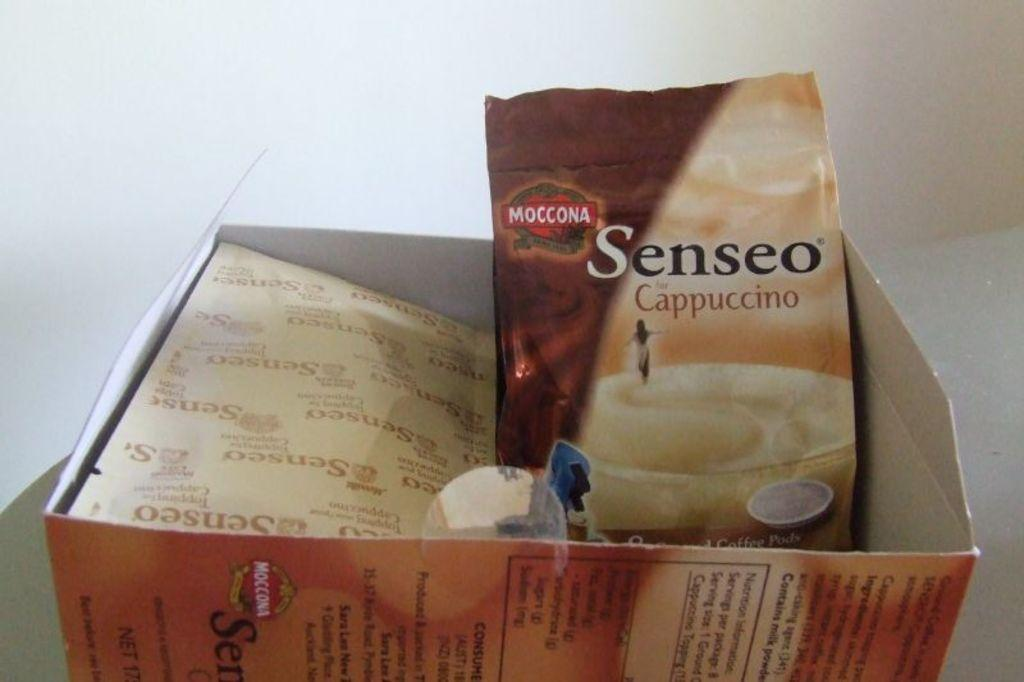<image>
Describe the image concisely. A box of Senseo Cappuccino is opened and contains a number of packets. 